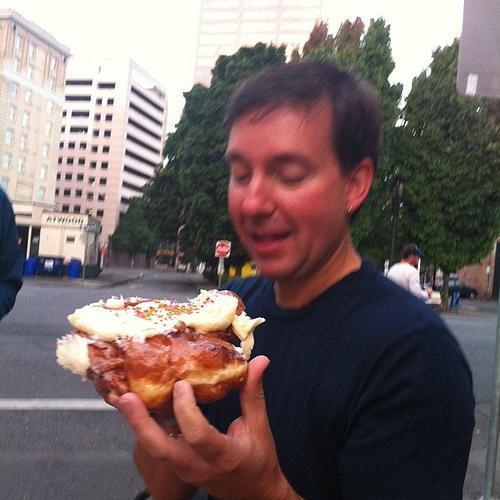How many pastries is the man holding?
Give a very brief answer. 1. How many people are wearing a white shirt?
Give a very brief answer. 1. 